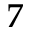Convert formula to latex. <formula><loc_0><loc_0><loc_500><loc_500>7</formula> 